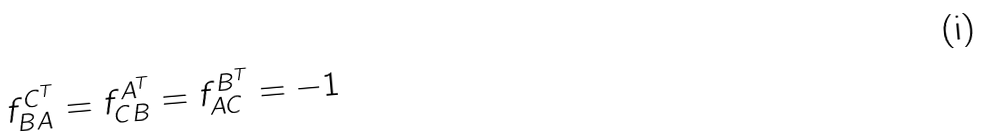<formula> <loc_0><loc_0><loc_500><loc_500>f _ { B A } ^ { C ^ { T } } = f _ { C B } ^ { A ^ { T } } = f _ { A C } ^ { B ^ { T } } = - 1</formula> 